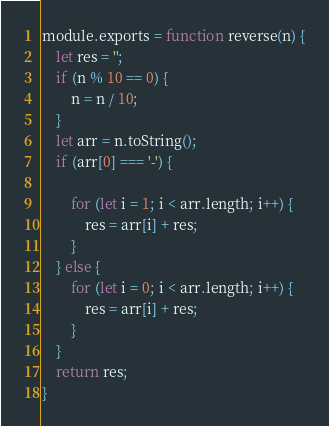<code> <loc_0><loc_0><loc_500><loc_500><_JavaScript_>module.exports = function reverse(n) {
    let res = '';
    if (n % 10 == 0) {
        n = n / 10;
    }
    let arr = n.toString();
    if (arr[0] === '-') {

        for (let i = 1; i < arr.length; i++) {
            res = arr[i] + res;
        }
    } else {
        for (let i = 0; i < arr.length; i++) {
            res = arr[i] + res;
        }
    }
    return res;
}
</code> 